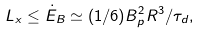Convert formula to latex. <formula><loc_0><loc_0><loc_500><loc_500>L _ { x } \leq \dot { E } _ { B } \simeq ( 1 / 6 ) B _ { p } ^ { 2 } R ^ { 3 } / \tau _ { d } ,</formula> 